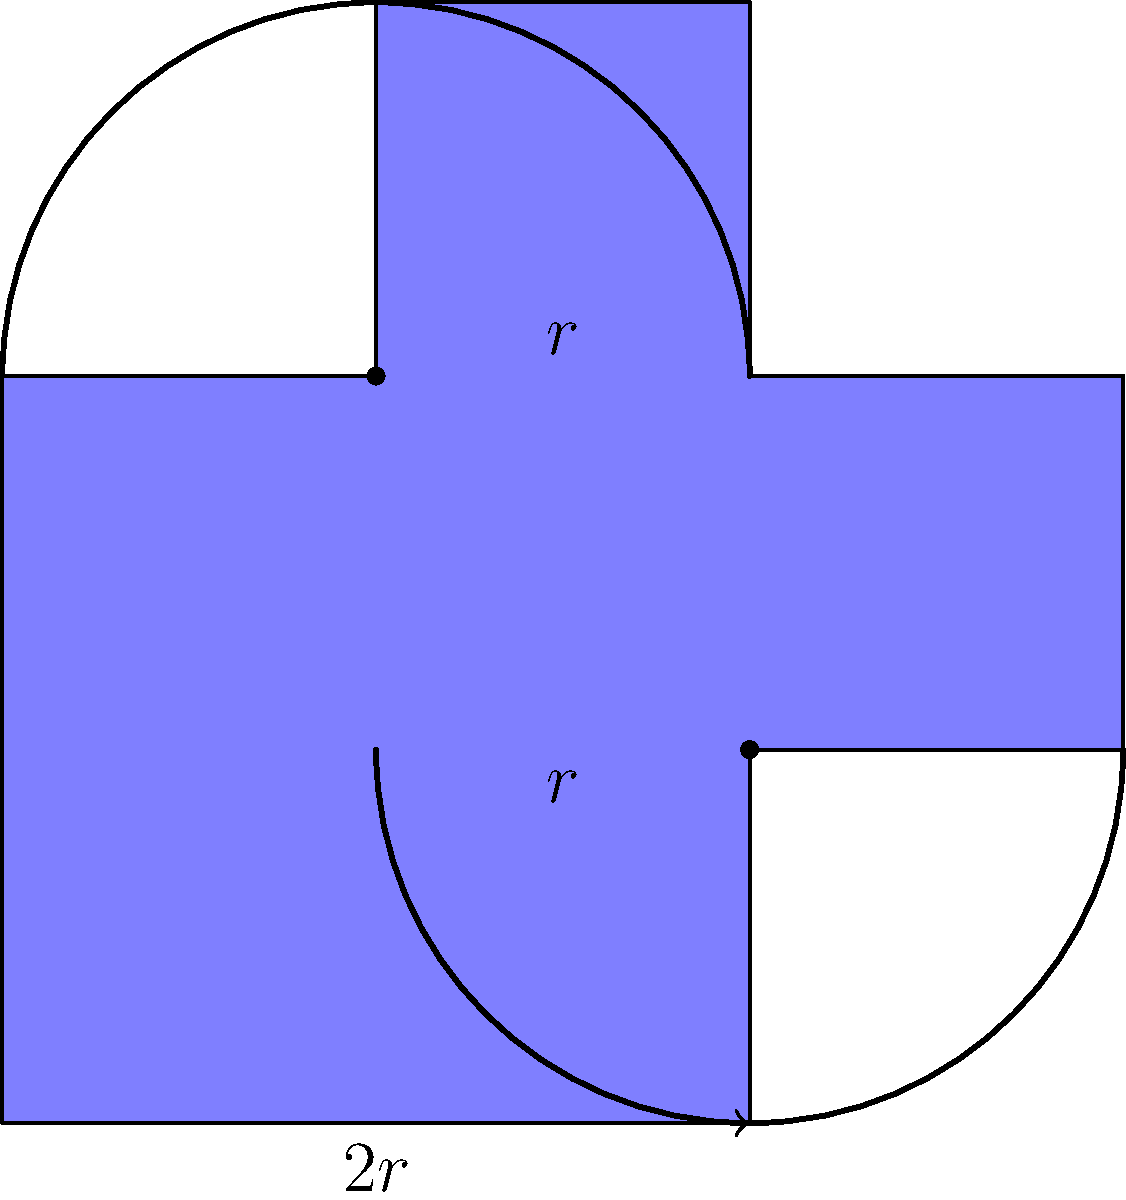In the Ethiopian Orthodox cross design shown above, two semicircles of radius $r$ are combined with a rectangular shape. If the width of the rectangular part is $2r$ and its height is $3r$, what is the perimeter of the entire cross in terms of $r$? Let's break this down step-by-step:

1) First, let's identify the components of the perimeter:
   - Two semicircles
   - The straight edges of the rectangular part not covered by the semicircles

2) For the semicircles:
   - The perimeter of a full circle is $2\pi r$
   - We have two semicircles, so that's equivalent to one full circle
   - Contribution from semicircles = $2\pi r$

3) For the straight edges:
   - Left side: $3r$
   - Right side: $3r$
   - Top: $r$ (because $1r$ is covered by the semicircle)
   - Bottom: $r$ (because $1r$ is covered by the semicircle)
   - Total straight edges = $3r + 3r + r + r = 8r$

4) Total perimeter:
   - Perimeter = Semicircles + Straight edges
   - Perimeter = $2\pi r + 8r$
   - Perimeter = $r(2\pi + 8)$

Therefore, the perimeter of the entire cross is $r(2\pi + 8)$.
Answer: $r(2\pi + 8)$ 